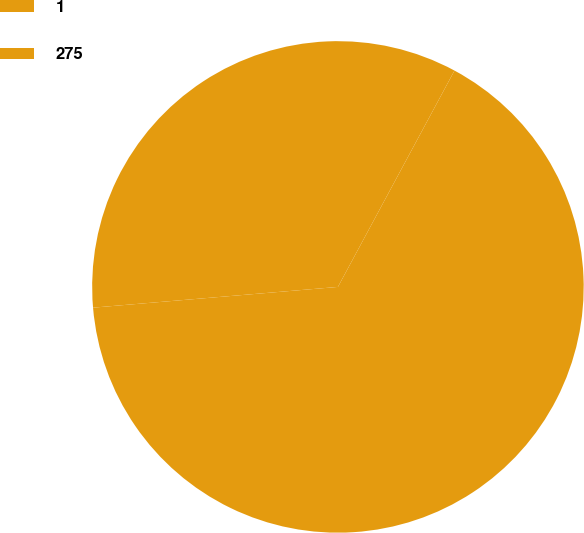Convert chart. <chart><loc_0><loc_0><loc_500><loc_500><pie_chart><fcel>1<fcel>275<nl><fcel>65.79%<fcel>34.21%<nl></chart> 